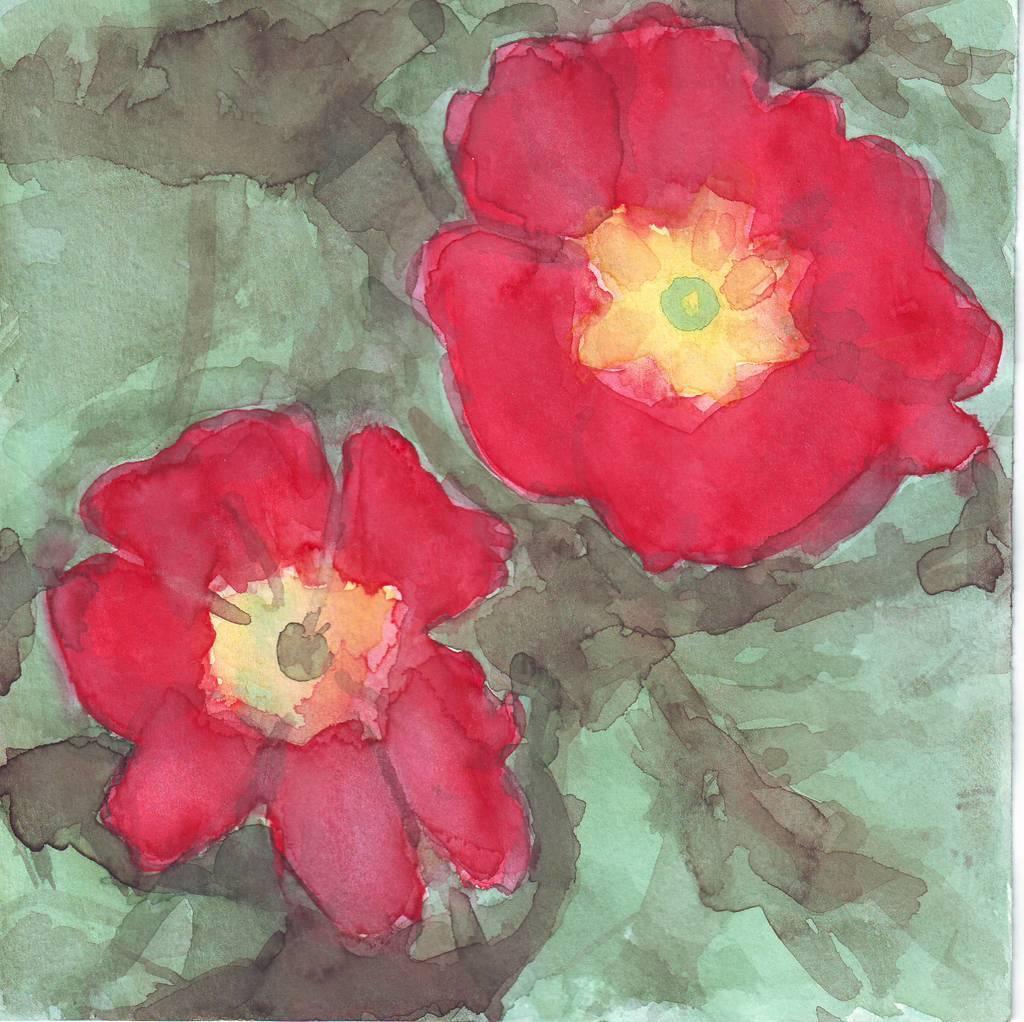Could you give a brief overview of what you see in this image? In this image I can see a painting of two red color flowers. 